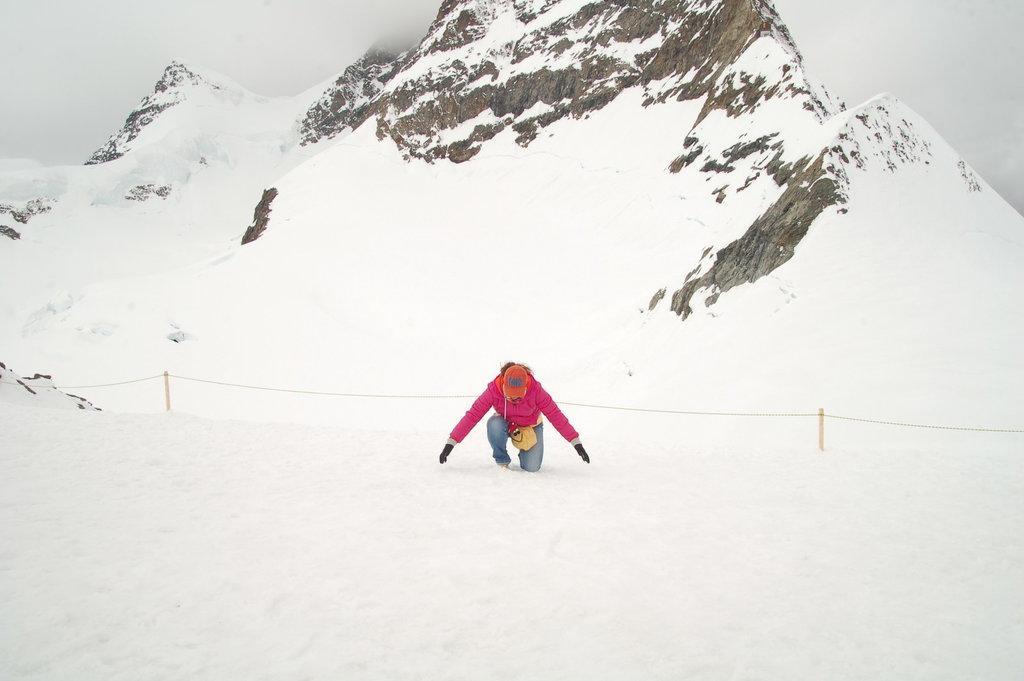How would you summarize this image in a sentence or two? In the foreground of this image, there is a person kneeling down on one knee on the snow. In the background, there is a railing, mountain and the sky. 